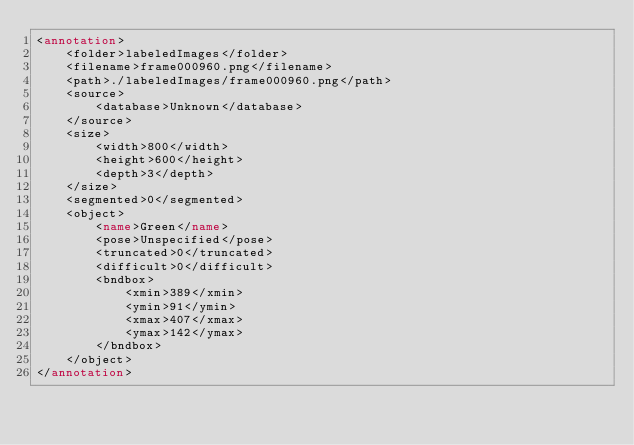<code> <loc_0><loc_0><loc_500><loc_500><_XML_><annotation>
	<folder>labeledImages</folder>
	<filename>frame000960.png</filename>
	<path>./labeledImages/frame000960.png</path>
	<source>
		<database>Unknown</database>
	</source>
	<size>
		<width>800</width>
		<height>600</height>
		<depth>3</depth>
	</size>
	<segmented>0</segmented>
	<object>
		<name>Green</name>
		<pose>Unspecified</pose>
		<truncated>0</truncated>
		<difficult>0</difficult>
		<bndbox>
			<xmin>389</xmin>
			<ymin>91</ymin>
			<xmax>407</xmax>
			<ymax>142</ymax>
		</bndbox>
	</object>
</annotation>
</code> 